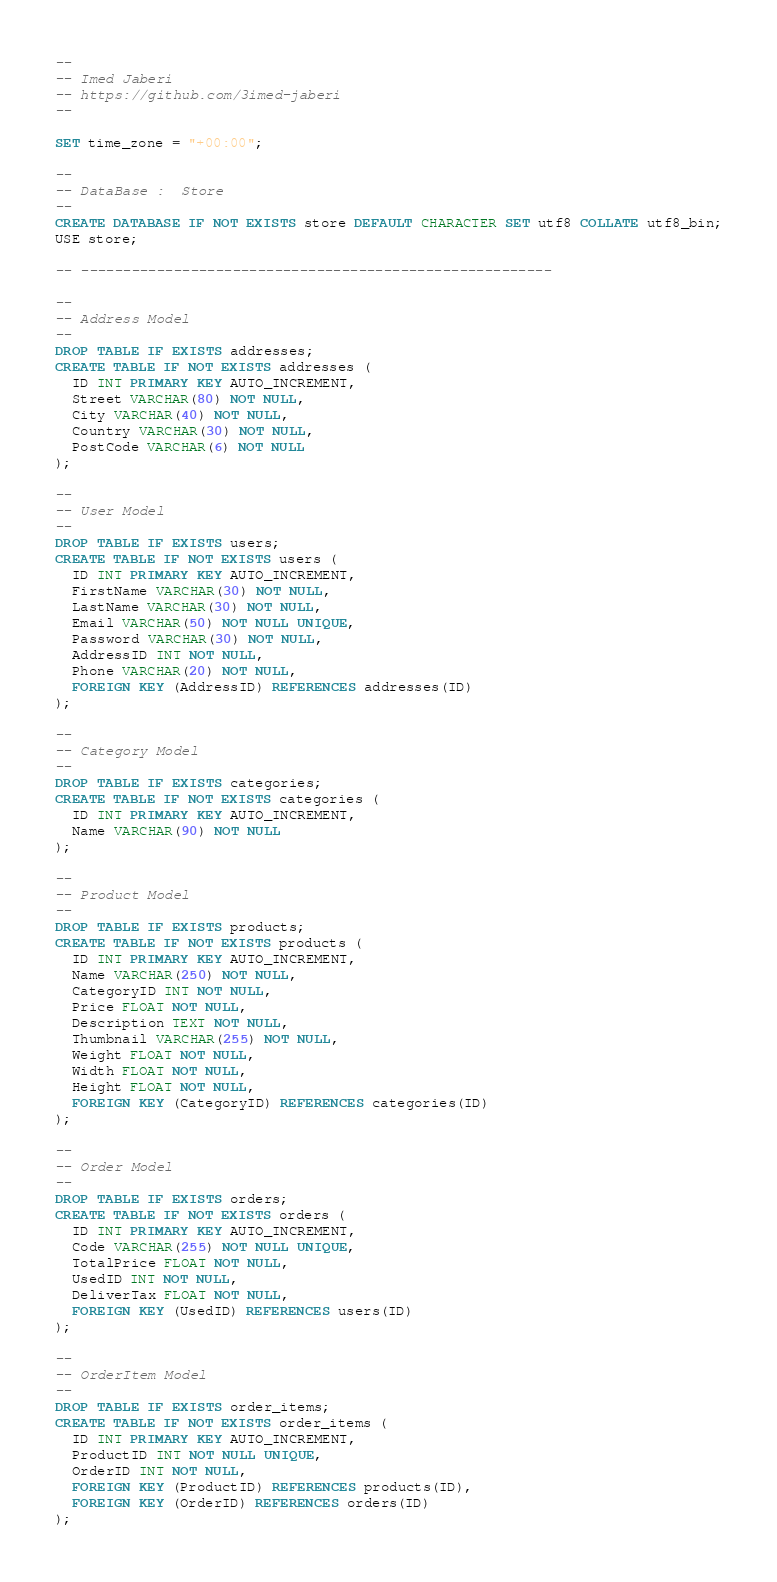<code> <loc_0><loc_0><loc_500><loc_500><_SQL_>--
-- Imed Jaberi 
-- https://github.com/3imed-jaberi
-- 

SET time_zone = "+00:00";

--
-- DataBase :  Store
--
CREATE DATABASE IF NOT EXISTS store DEFAULT CHARACTER SET utf8 COLLATE utf8_bin;
USE store;

-- --------------------------------------------------------

--
-- Address Model 
--
DROP TABLE IF EXISTS addresses;
CREATE TABLE IF NOT EXISTS addresses (
  ID INT PRIMARY KEY AUTO_INCREMENT,
  Street VARCHAR(80) NOT NULL,
  City VARCHAR(40) NOT NULL,
  Country VARCHAR(30) NOT NULL,
  PostCode VARCHAR(6) NOT NULL 
);

--
-- User Model 
--
DROP TABLE IF EXISTS users;
CREATE TABLE IF NOT EXISTS users (
  ID INT PRIMARY KEY AUTO_INCREMENT,
  FirstName VARCHAR(30) NOT NULL,
  LastName VARCHAR(30) NOT NULL,
  Email VARCHAR(50) NOT NULL UNIQUE,
  Password VARCHAR(30) NOT NULL,
  AddressID INT NOT NULL,
  Phone VARCHAR(20) NOT NULL,
  FOREIGN KEY (AddressID) REFERENCES addresses(ID)
);

--
-- Category Model 
--
DROP TABLE IF EXISTS categories;
CREATE TABLE IF NOT EXISTS categories (
  ID INT PRIMARY KEY AUTO_INCREMENT,
  Name VARCHAR(90) NOT NULL
);

--
-- Product Model 
--
DROP TABLE IF EXISTS products;
CREATE TABLE IF NOT EXISTS products (
  ID INT PRIMARY KEY AUTO_INCREMENT,
  Name VARCHAR(250) NOT NULL,
  CategoryID INT NOT NULL,
  Price FLOAT NOT NULL,
  Description TEXT NOT NULL,
  Thumbnail VARCHAR(255) NOT NULL,
  Weight FLOAT NOT NULL,
  Width FLOAT NOT NULL,
  Height FLOAT NOT NULL,
  FOREIGN KEY (CategoryID) REFERENCES categories(ID)
);

--
-- Order Model 
--
DROP TABLE IF EXISTS orders;
CREATE TABLE IF NOT EXISTS orders (
  ID INT PRIMARY KEY AUTO_INCREMENT,
  Code VARCHAR(255) NOT NULL UNIQUE,
  TotalPrice FLOAT NOT NULL,
  UsedID INT NOT NULL,
  DeliverTax FLOAT NOT NULL,
  FOREIGN KEY (UsedID) REFERENCES users(ID)
);

--
-- OrderItem Model 
--
DROP TABLE IF EXISTS order_items;
CREATE TABLE IF NOT EXISTS order_items (
  ID INT PRIMARY KEY AUTO_INCREMENT,
  ProductID INT NOT NULL UNIQUE,
  OrderID INT NOT NULL,
  FOREIGN KEY (ProductID) REFERENCES products(ID),
  FOREIGN KEY (OrderID) REFERENCES orders(ID)
);</code> 